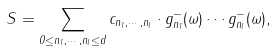Convert formula to latex. <formula><loc_0><loc_0><loc_500><loc_500>S = \sum _ { 0 \leq n _ { 1 } , \cdots , n _ { l } \leq d } c _ { n _ { 1 } , \cdots , n _ { l } } \cdot g _ { n _ { 1 } } ^ { - } ( \omega ) \cdots g _ { n _ { l } } ^ { - } ( \omega ) ,</formula> 